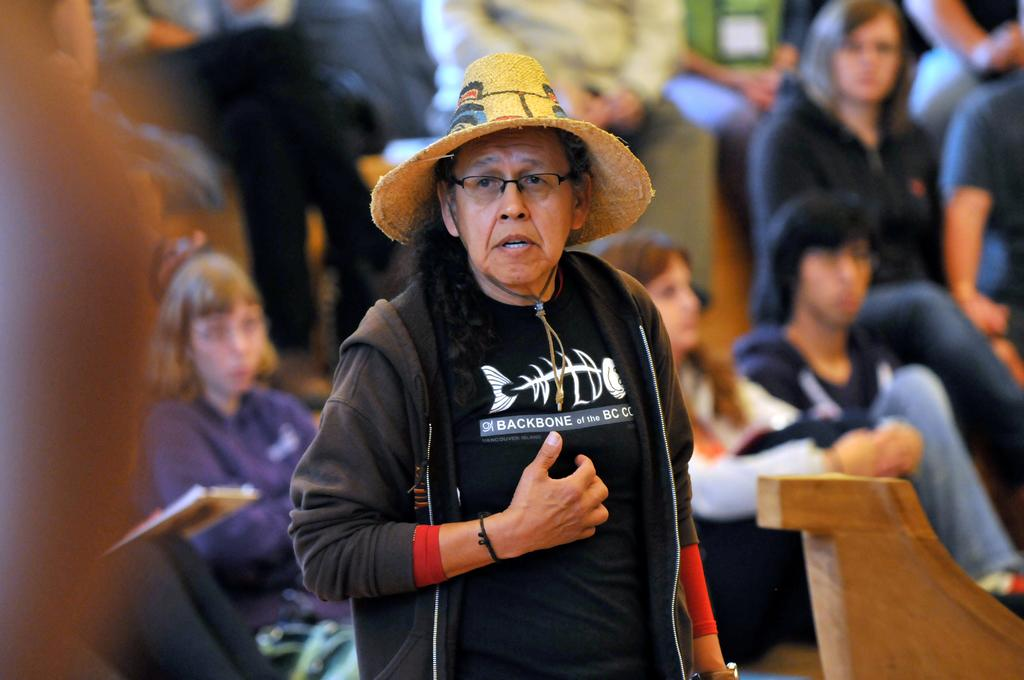Who is the main subject in the foreground of the image? There is a woman in the foreground of the image. What is the woman wearing in the image? The woman is wearing a black colored dress and a brown hat. What can be seen in the background of the image? There are persons sitting in the background of the image. What type of light is being used to illuminate the dirt in the image? There is no dirt present in the image, and therefore no light is being used to illuminate it. 